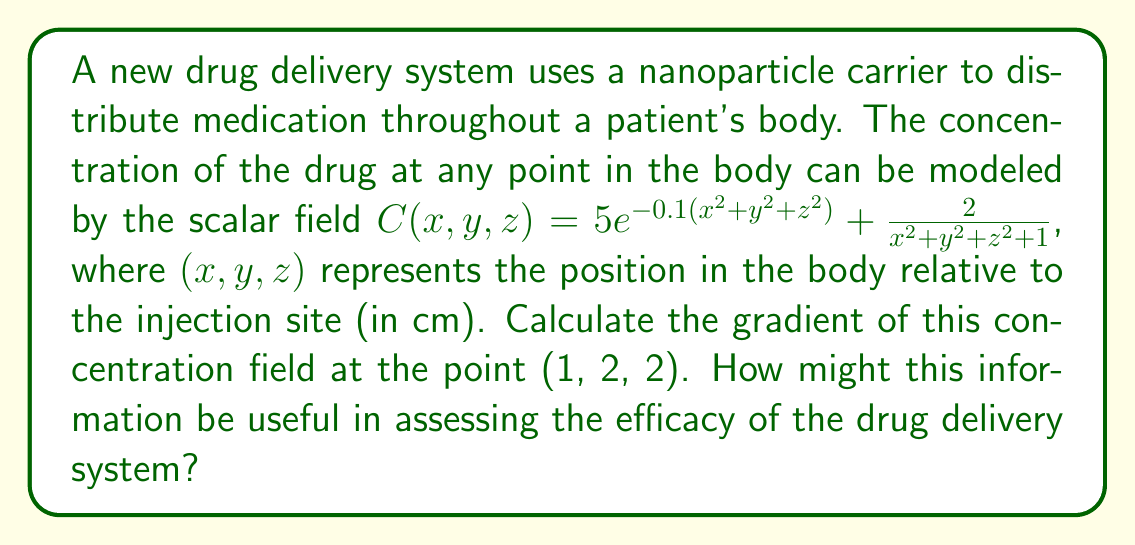What is the answer to this math problem? To solve this problem, we need to calculate the gradient of the scalar field $C(x,y,z)$. The gradient is a vector field that points in the direction of the steepest increase of the scalar field. It is defined as:

$$\nabla C = \left(\frac{\partial C}{\partial x}, \frac{\partial C}{\partial y}, \frac{\partial C}{\partial z}\right)$$

Let's calculate each partial derivative:

1) $\frac{\partial C}{\partial x}$:
   $$\frac{\partial C}{\partial x} = 5e^{-0.1(x^2+y^2+z^2)}(-0.2x) + \frac{-4x}{(x^2+y^2+z^2+1)^2}$$

2) $\frac{\partial C}{\partial y}$:
   $$\frac{\partial C}{\partial y} = 5e^{-0.1(x^2+y^2+z^2)}(-0.2y) + \frac{-4y}{(x^2+y^2+z^2+1)^2}$$

3) $\frac{\partial C}{\partial z}$:
   $$\frac{\partial C}{\partial z} = 5e^{-0.1(x^2+y^2+z^2)}(-0.2z) + \frac{-4z}{(x^2+y^2+z^2+1)^2}$$

Now, we need to evaluate these at the point (1, 2, 2):

$$\nabla C(1,2,2) = \left(
5e^{-0.1(1^2+2^2+2^2)}(-0.2(1)) + \frac{-4(1)}{(1^2+2^2+2^2+1)^2},
5e^{-0.1(1^2+2^2+2^2)}(-0.2(2)) + \frac{-4(2)}{(1^2+2^2+2^2+1)^2},
5e^{-0.1(1^2+2^2+2^2)}(-0.2(2)) + \frac{-4(2)}{(1^2+2^2+2^2+1)^2}
\right)$$

Simplifying:

$$\nabla C(1,2,2) = \left(
-e^{-0.9}(1) - \frac{4}{10^2},
-2e^{-0.9}(1) - \frac{8}{10^2},
-2e^{-0.9}(1) - \frac{8}{10^2}
\right)$$

$$\nabla C(1,2,2) \approx (-0.4065, -0.8130, -0.8130)$$

This gradient vector indicates the direction of steepest increase in drug concentration at the point (1, 2, 2) cm from the injection site. The negative values suggest that the concentration is decreasing in all directions at this point, with the rate of decrease being higher in the y and z directions compared to the x direction.

This information is crucial for assessing the efficacy of the drug delivery system. It helps in understanding how the drug spreads from the injection site, which areas of the body might receive higher or lower doses, and how quickly the concentration changes in different directions. This can be used to optimize the delivery system, predict potential side effects, and ensure that the drug reaches its intended targets effectively.
Answer: $\nabla C(1,2,2) \approx (-0.4065, -0.8130, -0.8130)$ 